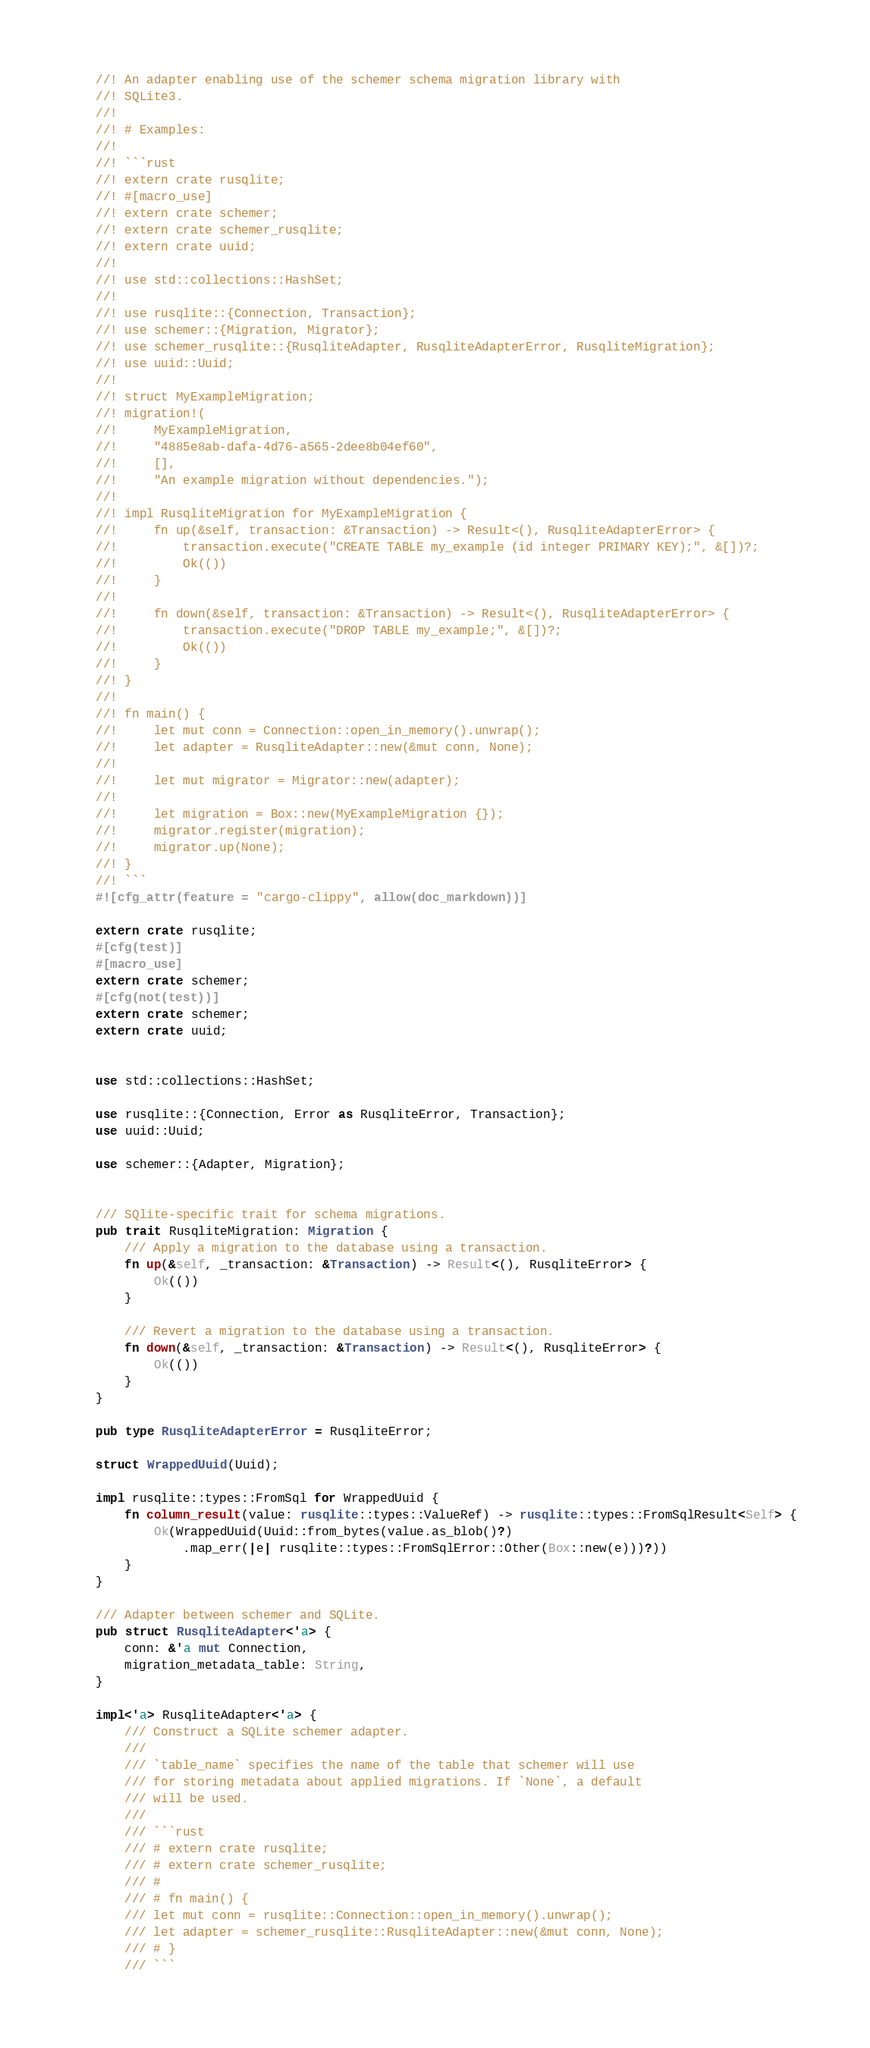Convert code to text. <code><loc_0><loc_0><loc_500><loc_500><_Rust_>//! An adapter enabling use of the schemer schema migration library with
//! SQLite3.
//!
//! # Examples:
//!
//! ```rust
//! extern crate rusqlite;
//! #[macro_use]
//! extern crate schemer;
//! extern crate schemer_rusqlite;
//! extern crate uuid;
//!
//! use std::collections::HashSet;
//!
//! use rusqlite::{Connection, Transaction};
//! use schemer::{Migration, Migrator};
//! use schemer_rusqlite::{RusqliteAdapter, RusqliteAdapterError, RusqliteMigration};
//! use uuid::Uuid;
//!
//! struct MyExampleMigration;
//! migration!(
//!     MyExampleMigration,
//!     "4885e8ab-dafa-4d76-a565-2dee8b04ef60",
//!     [],
//!     "An example migration without dependencies.");
//!
//! impl RusqliteMigration for MyExampleMigration {
//!     fn up(&self, transaction: &Transaction) -> Result<(), RusqliteAdapterError> {
//!         transaction.execute("CREATE TABLE my_example (id integer PRIMARY KEY);", &[])?;
//!         Ok(())
//!     }
//!
//!     fn down(&self, transaction: &Transaction) -> Result<(), RusqliteAdapterError> {
//!         transaction.execute("DROP TABLE my_example;", &[])?;
//!         Ok(())
//!     }
//! }
//!
//! fn main() {
//!     let mut conn = Connection::open_in_memory().unwrap();
//!     let adapter = RusqliteAdapter::new(&mut conn, None);
//!
//!     let mut migrator = Migrator::new(adapter);
//!
//!     let migration = Box::new(MyExampleMigration {});
//!     migrator.register(migration);
//!     migrator.up(None);
//! }
//! ```
#![cfg_attr(feature = "cargo-clippy", allow(doc_markdown))]

extern crate rusqlite;
#[cfg(test)]
#[macro_use]
extern crate schemer;
#[cfg(not(test))]
extern crate schemer;
extern crate uuid;


use std::collections::HashSet;

use rusqlite::{Connection, Error as RusqliteError, Transaction};
use uuid::Uuid;

use schemer::{Adapter, Migration};


/// SQlite-specific trait for schema migrations.
pub trait RusqliteMigration: Migration {
    /// Apply a migration to the database using a transaction.
    fn up(&self, _transaction: &Transaction) -> Result<(), RusqliteError> {
        Ok(())
    }

    /// Revert a migration to the database using a transaction.
    fn down(&self, _transaction: &Transaction) -> Result<(), RusqliteError> {
        Ok(())
    }
}

pub type RusqliteAdapterError = RusqliteError;

struct WrappedUuid(Uuid);

impl rusqlite::types::FromSql for WrappedUuid {
    fn column_result(value: rusqlite::types::ValueRef) -> rusqlite::types::FromSqlResult<Self> {
        Ok(WrappedUuid(Uuid::from_bytes(value.as_blob()?)
            .map_err(|e| rusqlite::types::FromSqlError::Other(Box::new(e)))?))
    }
}

/// Adapter between schemer and SQLite.
pub struct RusqliteAdapter<'a> {
    conn: &'a mut Connection,
    migration_metadata_table: String,
}

impl<'a> RusqliteAdapter<'a> {
    /// Construct a SQLite schemer adapter.
    ///
    /// `table_name` specifies the name of the table that schemer will use
    /// for storing metadata about applied migrations. If `None`, a default
    /// will be used.
    ///
    /// ```rust
    /// # extern crate rusqlite;
    /// # extern crate schemer_rusqlite;
    /// #
    /// # fn main() {
    /// let mut conn = rusqlite::Connection::open_in_memory().unwrap();
    /// let adapter = schemer_rusqlite::RusqliteAdapter::new(&mut conn, None);
    /// # }
    /// ```</code> 